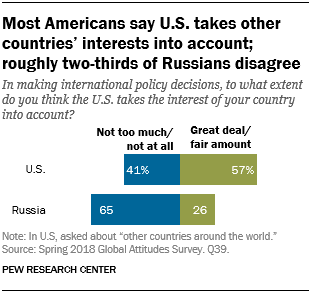Point out several critical features in this image. In the US category, the next data is 41%. In Russia, the ratio of those who find a great deal of information to be not too much or not at all, to those who find it to be a fair amount, is 2.768055556... 